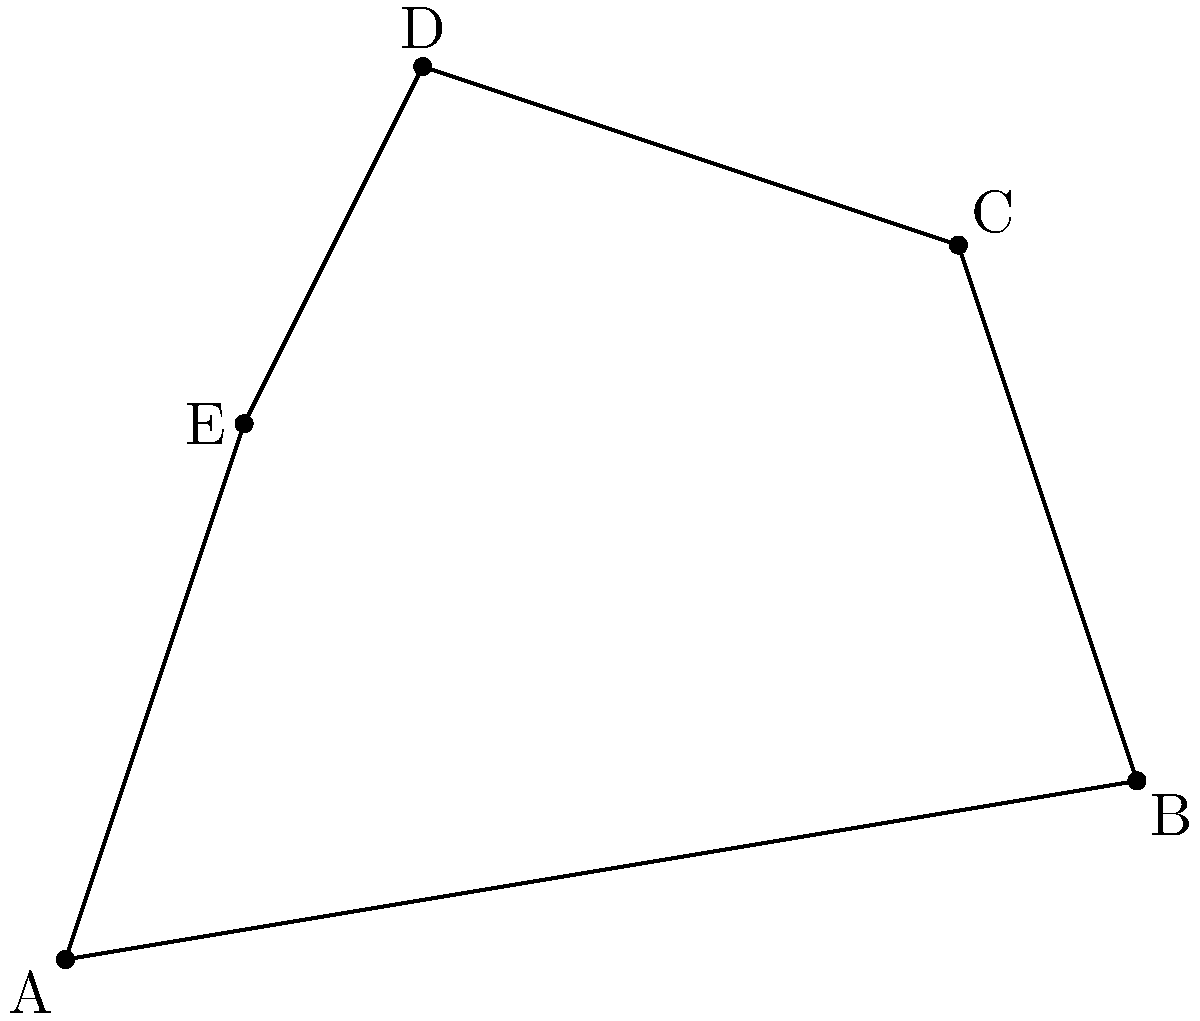As an innovative painter, you're experimenting with a new canvas shape for your next masterpiece. The canvas is represented by the irregular pentagon ABCDE on a coordinate grid, where A(0,0), B(6,1), C(5,4), D(2,5), and E(1,3) are the vertices. Calculate the area of this unique canvas shape using coordinate geometry methods. To find the area of the irregular pentagon, we can use the Shoelace formula (also known as the surveyor's formula). This method involves calculating the determinants of adjacent coordinate pairs.

Step 1: List the coordinates in order, repeating the first coordinate at the end:
A(0,0), B(6,1), C(5,4), D(2,5), E(1,3), A(0,0)

Step 2: Apply the Shoelace formula:
Area = $\frac{1}{2}|[(x_1y_2 + x_2y_3 + x_3y_4 + x_4y_5 + x_5y_6) - (y_1x_2 + y_2x_3 + y_3x_4 + y_4x_5 + y_5x_6)]|$

Step 3: Substitute the values:
Area = $\frac{1}{2}|[(0 \cdot 1 + 6 \cdot 4 + 5 \cdot 5 + 2 \cdot 3 + 1 \cdot 0) - (0 \cdot 6 + 1 \cdot 5 + 4 \cdot 2 + 5 \cdot 1 + 3 \cdot 0)]|$

Step 4: Calculate:
Area = $\frac{1}{2}|[(0 + 24 + 25 + 6 + 0) - (0 + 5 + 8 + 5 + 0)]|$
Area = $\frac{1}{2}|[55 - 18]|$
Area = $\frac{1}{2}|37|$
Area = $\frac{37}{2}$ = 18.5 square units

Therefore, the area of the irregular pentagon is 18.5 square units.
Answer: 18.5 square units 